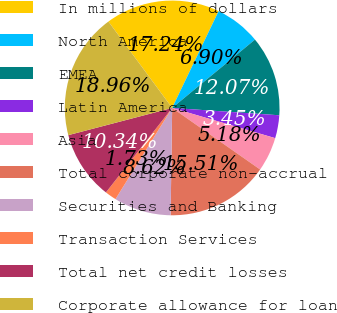Convert chart. <chart><loc_0><loc_0><loc_500><loc_500><pie_chart><fcel>In millions of dollars<fcel>North America<fcel>EMEA<fcel>Latin America<fcel>Asia<fcel>Total corporate non-accrual<fcel>Securities and Banking<fcel>Transaction Services<fcel>Total net credit losses<fcel>Corporate allowance for loan<nl><fcel>17.24%<fcel>6.9%<fcel>12.07%<fcel>3.45%<fcel>5.18%<fcel>15.51%<fcel>8.62%<fcel>1.73%<fcel>10.34%<fcel>18.96%<nl></chart> 